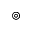Convert formula to latex. <formula><loc_0><loc_0><loc_500><loc_500>\circledcirc</formula> 